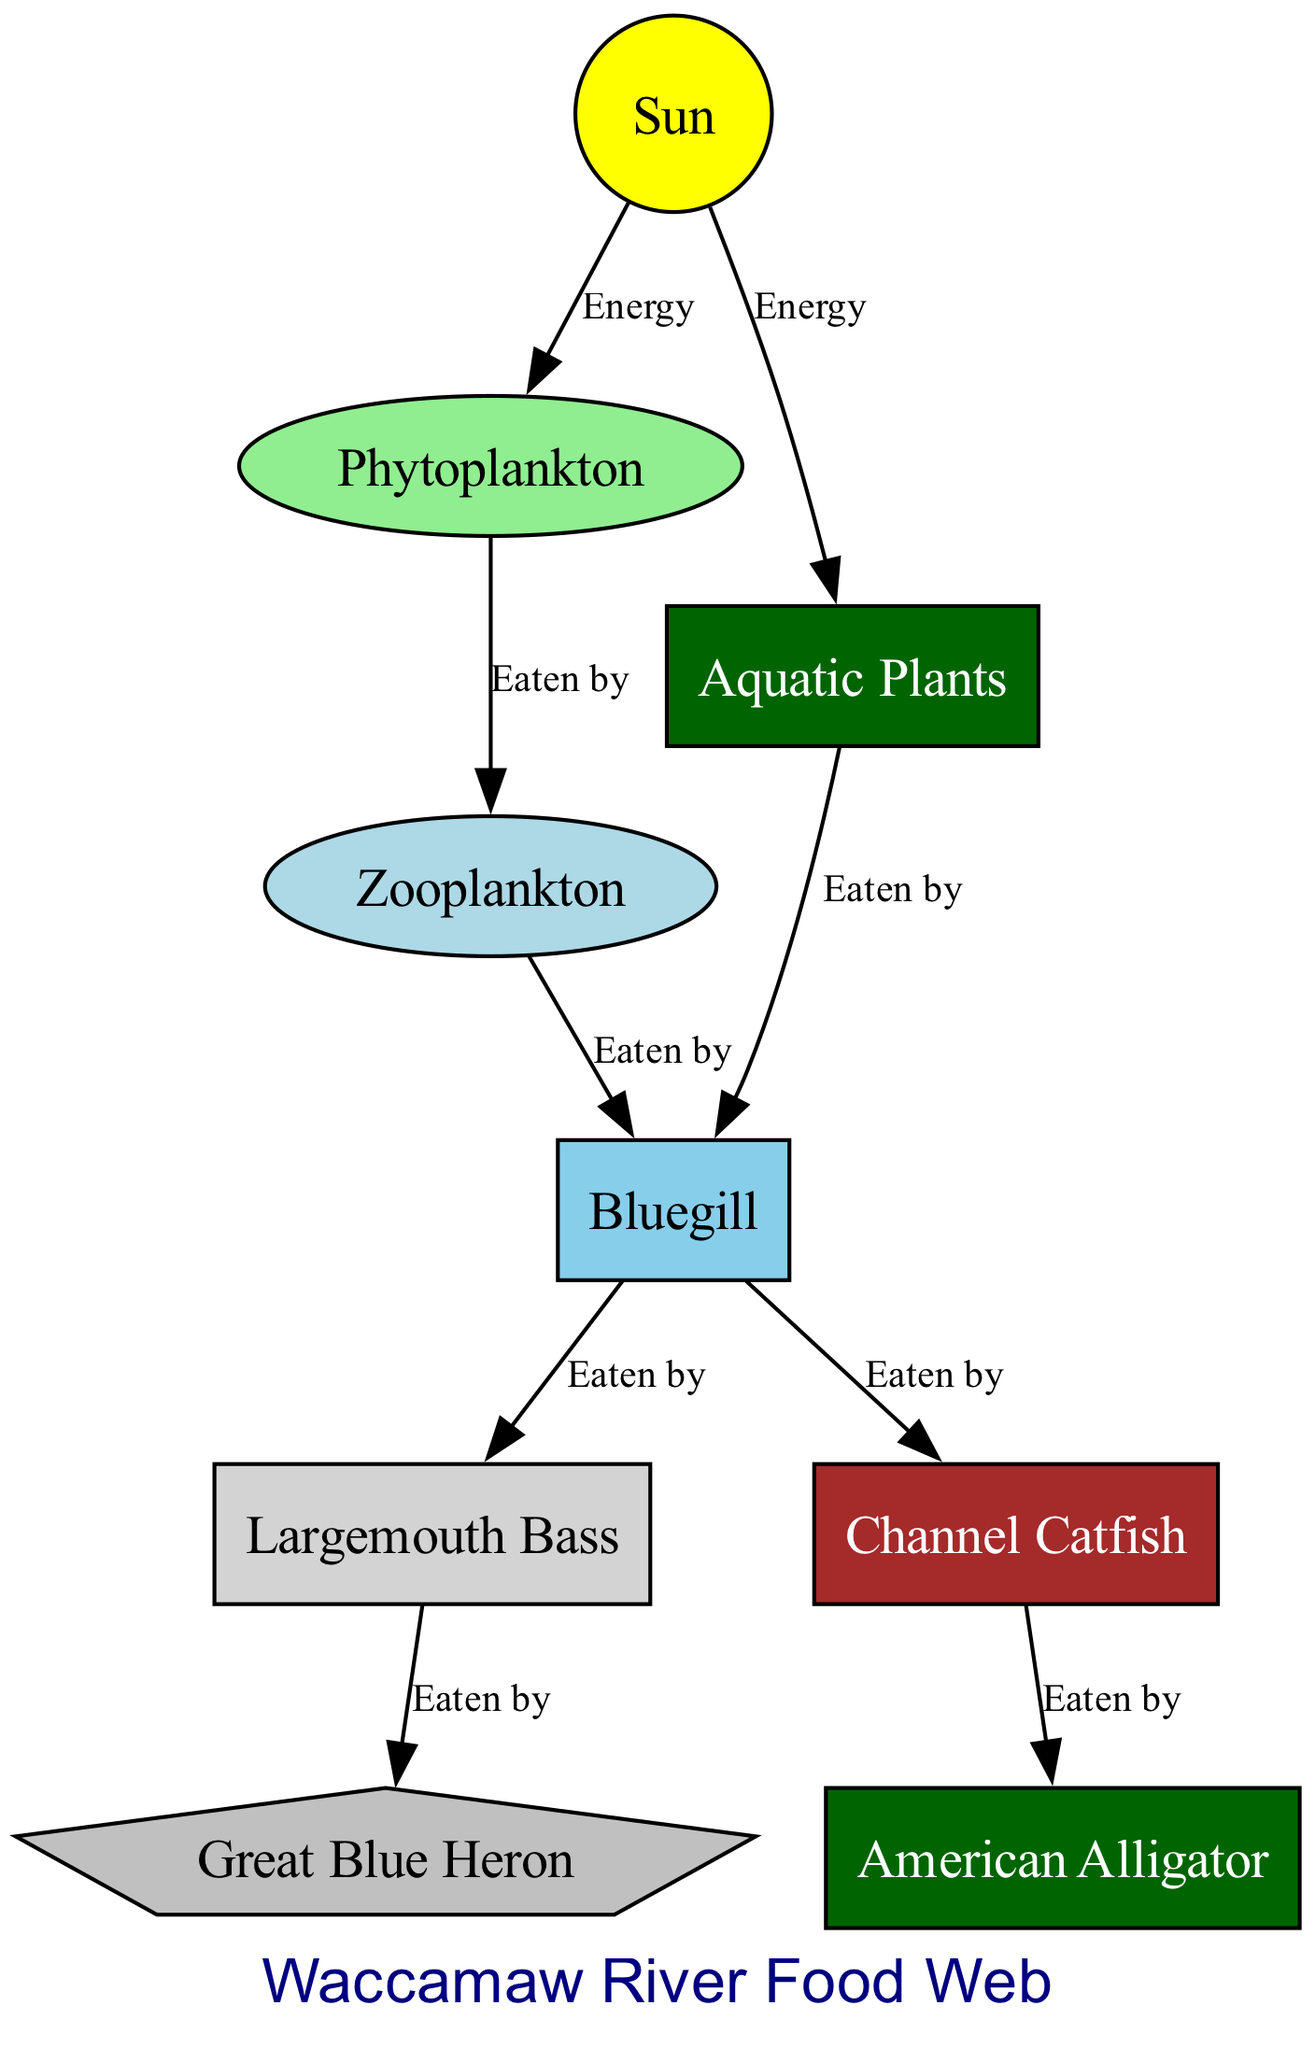What is the primary energy source in the food web? The primary energy source in the food web is the sun, as indicated by the arrows pointing from "sun" to both "phytoplankton" and "aquatic plants." This shows that the sun provides energy to these primary producers, which are the starting point for energy flow in the ecosystem.
Answer: Sun How many species are directly eaten by the bluegill? The bluegill is eaten by two species (bass and channel catfish). This can be deduced by looking at the edges leading out from the bluegill node, which shows that it has connections to both bass and catfish under the label "Eaten by."
Answer: 2 Which species is the top predator in the food web? The top predator in this food web is the American Alligator, as it is the only species that is not shown to be eaten by any other species in the diagram. Predators are typically at the higher trophic levels, and since the alligator is not followed by any arrows leading away from it, it qualifies as the apex predator.
Answer: American Alligator How many total nodes represent species in the food web? There are eight total nodes representing species in the food web, including all the species listed such as the sun, phytoplankton, zooplankton, aquatic plants, bluegill, bass, catfish, and heron. Each listed name corresponds to a node in the diagram.
Answer: 8 Which aquatic plant is a food source for the bluegill? The aquatic plant that serves as a food source for the bluegill is aquatic plants, as shown by the edge that connects "aquatic plants" to "bluegill" with the label "Eaten by." This indicates that bluegills consume aquatic plants directly.
Answer: Aquatic Plants Who preys on the bass according to the diagram? The species that preys on the bass is the Great Blue Heron, as indicated by the edge from "bass" to "heron" labeled "Eaten by." This shows the direct predator-prey relationship between these two species.
Answer: Great Blue Heron Which organism is the first consumer in the food web? The first consumer in this food web is the zooplankton, which consumes phytoplankton. This is identified by the edge showing the relationship where "phytoplankton" is eaten by "zooplankton." Consumers are organisms that eat producers or other consumers, and zooplankton fits this definition as it takes in phytoplankton.
Answer: Zooplankton What do phytoplankton consume? Phytoplankton do not consume anything; instead, they are primary producers that utilize energy from the sun for photosynthesis. This is confirmed by the diagram where there are arrows pointing from the sun to phytoplankton, showing energy input rather than consumption.
Answer: Nothing 